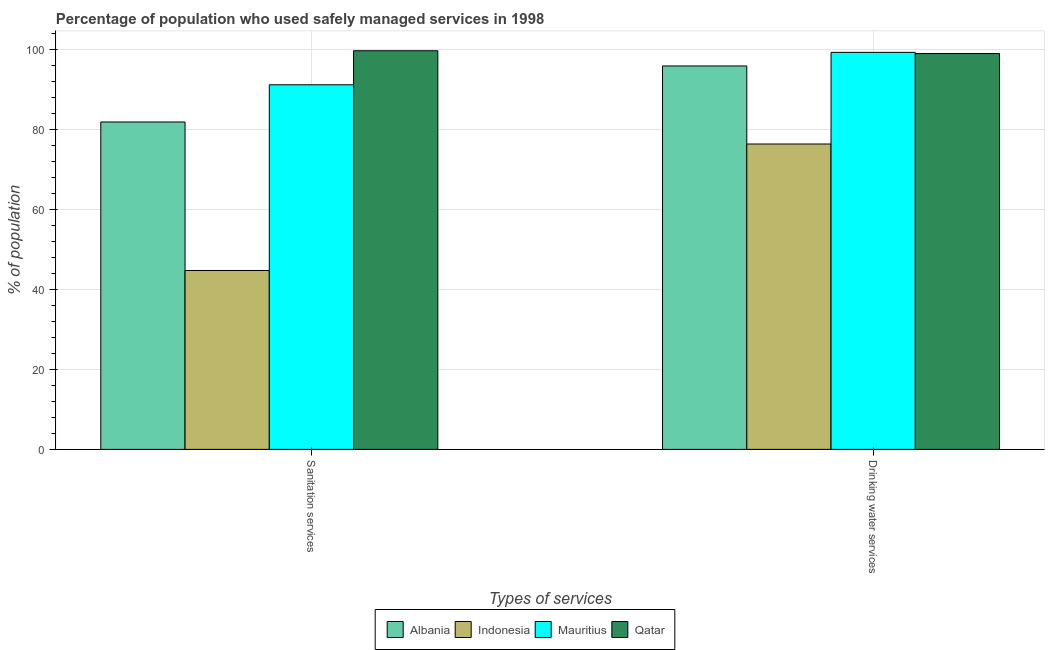How many different coloured bars are there?
Ensure brevity in your answer.  4. How many groups of bars are there?
Provide a succinct answer. 2. Are the number of bars per tick equal to the number of legend labels?
Make the answer very short. Yes. Are the number of bars on each tick of the X-axis equal?
Offer a terse response. Yes. How many bars are there on the 2nd tick from the right?
Provide a short and direct response. 4. What is the label of the 2nd group of bars from the left?
Give a very brief answer. Drinking water services. What is the percentage of population who used drinking water services in Qatar?
Your response must be concise. 98.9. Across all countries, what is the maximum percentage of population who used sanitation services?
Offer a very short reply. 99.6. Across all countries, what is the minimum percentage of population who used drinking water services?
Offer a very short reply. 76.3. In which country was the percentage of population who used sanitation services maximum?
Ensure brevity in your answer.  Qatar. In which country was the percentage of population who used sanitation services minimum?
Provide a succinct answer. Indonesia. What is the total percentage of population who used sanitation services in the graph?
Your response must be concise. 317.2. What is the difference between the percentage of population who used drinking water services in Qatar and that in Albania?
Provide a short and direct response. 3.1. What is the difference between the percentage of population who used drinking water services in Mauritius and the percentage of population who used sanitation services in Indonesia?
Offer a very short reply. 54.5. What is the average percentage of population who used sanitation services per country?
Offer a very short reply. 79.3. What is the difference between the percentage of population who used sanitation services and percentage of population who used drinking water services in Qatar?
Make the answer very short. 0.7. What is the ratio of the percentage of population who used drinking water services in Qatar to that in Albania?
Your answer should be compact. 1.03. In how many countries, is the percentage of population who used drinking water services greater than the average percentage of population who used drinking water services taken over all countries?
Keep it short and to the point. 3. What does the 4th bar from the left in Drinking water services represents?
Provide a succinct answer. Qatar. What does the 2nd bar from the right in Drinking water services represents?
Keep it short and to the point. Mauritius. How many bars are there?
Make the answer very short. 8. Are all the bars in the graph horizontal?
Ensure brevity in your answer.  No. How many countries are there in the graph?
Ensure brevity in your answer.  4. What is the difference between two consecutive major ticks on the Y-axis?
Ensure brevity in your answer.  20. Does the graph contain any zero values?
Your response must be concise. No. Does the graph contain grids?
Provide a succinct answer. Yes. How many legend labels are there?
Offer a terse response. 4. What is the title of the graph?
Offer a terse response. Percentage of population who used safely managed services in 1998. What is the label or title of the X-axis?
Your response must be concise. Types of services. What is the label or title of the Y-axis?
Provide a succinct answer. % of population. What is the % of population in Albania in Sanitation services?
Keep it short and to the point. 81.8. What is the % of population in Indonesia in Sanitation services?
Offer a terse response. 44.7. What is the % of population in Mauritius in Sanitation services?
Offer a very short reply. 91.1. What is the % of population in Qatar in Sanitation services?
Make the answer very short. 99.6. What is the % of population in Albania in Drinking water services?
Your response must be concise. 95.8. What is the % of population of Indonesia in Drinking water services?
Your answer should be very brief. 76.3. What is the % of population of Mauritius in Drinking water services?
Your answer should be very brief. 99.2. What is the % of population in Qatar in Drinking water services?
Give a very brief answer. 98.9. Across all Types of services, what is the maximum % of population of Albania?
Give a very brief answer. 95.8. Across all Types of services, what is the maximum % of population of Indonesia?
Provide a short and direct response. 76.3. Across all Types of services, what is the maximum % of population of Mauritius?
Keep it short and to the point. 99.2. Across all Types of services, what is the maximum % of population of Qatar?
Make the answer very short. 99.6. Across all Types of services, what is the minimum % of population in Albania?
Your response must be concise. 81.8. Across all Types of services, what is the minimum % of population in Indonesia?
Offer a terse response. 44.7. Across all Types of services, what is the minimum % of population of Mauritius?
Your answer should be compact. 91.1. Across all Types of services, what is the minimum % of population in Qatar?
Your answer should be very brief. 98.9. What is the total % of population in Albania in the graph?
Your answer should be very brief. 177.6. What is the total % of population in Indonesia in the graph?
Your answer should be compact. 121. What is the total % of population of Mauritius in the graph?
Your answer should be compact. 190.3. What is the total % of population in Qatar in the graph?
Your answer should be very brief. 198.5. What is the difference between the % of population in Albania in Sanitation services and that in Drinking water services?
Ensure brevity in your answer.  -14. What is the difference between the % of population in Indonesia in Sanitation services and that in Drinking water services?
Offer a terse response. -31.6. What is the difference between the % of population of Mauritius in Sanitation services and that in Drinking water services?
Provide a short and direct response. -8.1. What is the difference between the % of population of Qatar in Sanitation services and that in Drinking water services?
Give a very brief answer. 0.7. What is the difference between the % of population in Albania in Sanitation services and the % of population in Indonesia in Drinking water services?
Offer a terse response. 5.5. What is the difference between the % of population of Albania in Sanitation services and the % of population of Mauritius in Drinking water services?
Make the answer very short. -17.4. What is the difference between the % of population in Albania in Sanitation services and the % of population in Qatar in Drinking water services?
Make the answer very short. -17.1. What is the difference between the % of population of Indonesia in Sanitation services and the % of population of Mauritius in Drinking water services?
Your answer should be very brief. -54.5. What is the difference between the % of population in Indonesia in Sanitation services and the % of population in Qatar in Drinking water services?
Your response must be concise. -54.2. What is the average % of population in Albania per Types of services?
Your answer should be very brief. 88.8. What is the average % of population of Indonesia per Types of services?
Your response must be concise. 60.5. What is the average % of population of Mauritius per Types of services?
Your answer should be compact. 95.15. What is the average % of population in Qatar per Types of services?
Your response must be concise. 99.25. What is the difference between the % of population of Albania and % of population of Indonesia in Sanitation services?
Offer a terse response. 37.1. What is the difference between the % of population in Albania and % of population in Qatar in Sanitation services?
Offer a very short reply. -17.8. What is the difference between the % of population in Indonesia and % of population in Mauritius in Sanitation services?
Give a very brief answer. -46.4. What is the difference between the % of population of Indonesia and % of population of Qatar in Sanitation services?
Keep it short and to the point. -54.9. What is the difference between the % of population in Albania and % of population in Mauritius in Drinking water services?
Your response must be concise. -3.4. What is the difference between the % of population in Indonesia and % of population in Mauritius in Drinking water services?
Keep it short and to the point. -22.9. What is the difference between the % of population in Indonesia and % of population in Qatar in Drinking water services?
Ensure brevity in your answer.  -22.6. What is the difference between the % of population in Mauritius and % of population in Qatar in Drinking water services?
Provide a short and direct response. 0.3. What is the ratio of the % of population in Albania in Sanitation services to that in Drinking water services?
Give a very brief answer. 0.85. What is the ratio of the % of population of Indonesia in Sanitation services to that in Drinking water services?
Provide a succinct answer. 0.59. What is the ratio of the % of population of Mauritius in Sanitation services to that in Drinking water services?
Offer a terse response. 0.92. What is the ratio of the % of population of Qatar in Sanitation services to that in Drinking water services?
Give a very brief answer. 1.01. What is the difference between the highest and the second highest % of population of Albania?
Give a very brief answer. 14. What is the difference between the highest and the second highest % of population of Indonesia?
Offer a terse response. 31.6. What is the difference between the highest and the second highest % of population in Mauritius?
Your response must be concise. 8.1. What is the difference between the highest and the lowest % of population of Indonesia?
Provide a succinct answer. 31.6. What is the difference between the highest and the lowest % of population of Mauritius?
Ensure brevity in your answer.  8.1. What is the difference between the highest and the lowest % of population in Qatar?
Your answer should be very brief. 0.7. 